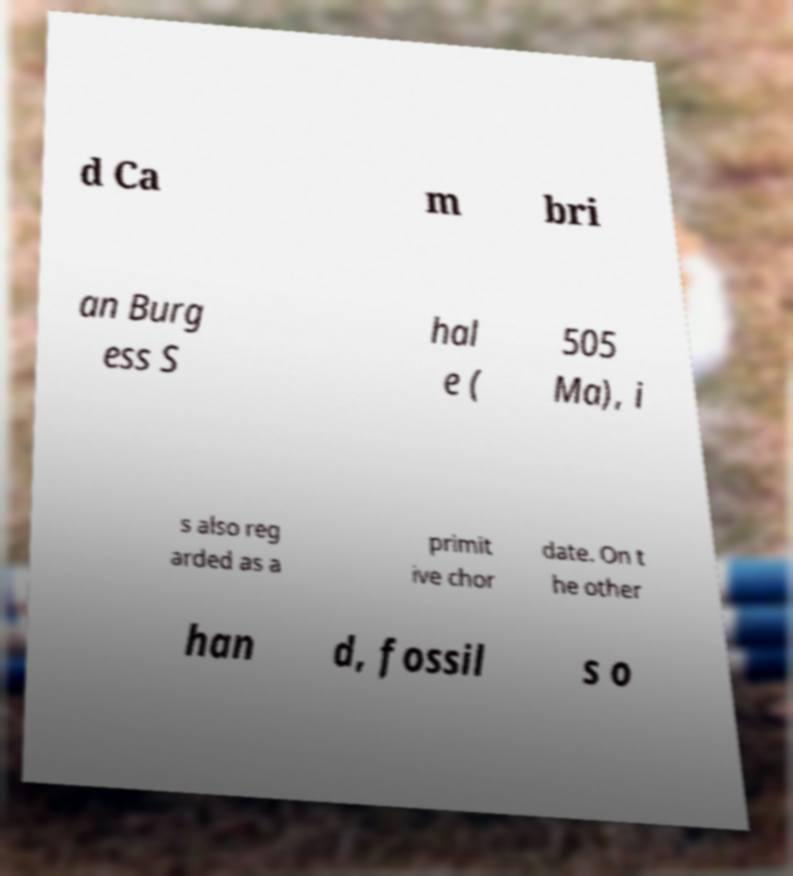Please read and relay the text visible in this image. What does it say? d Ca m bri an Burg ess S hal e ( 505 Ma), i s also reg arded as a primit ive chor date. On t he other han d, fossil s o 